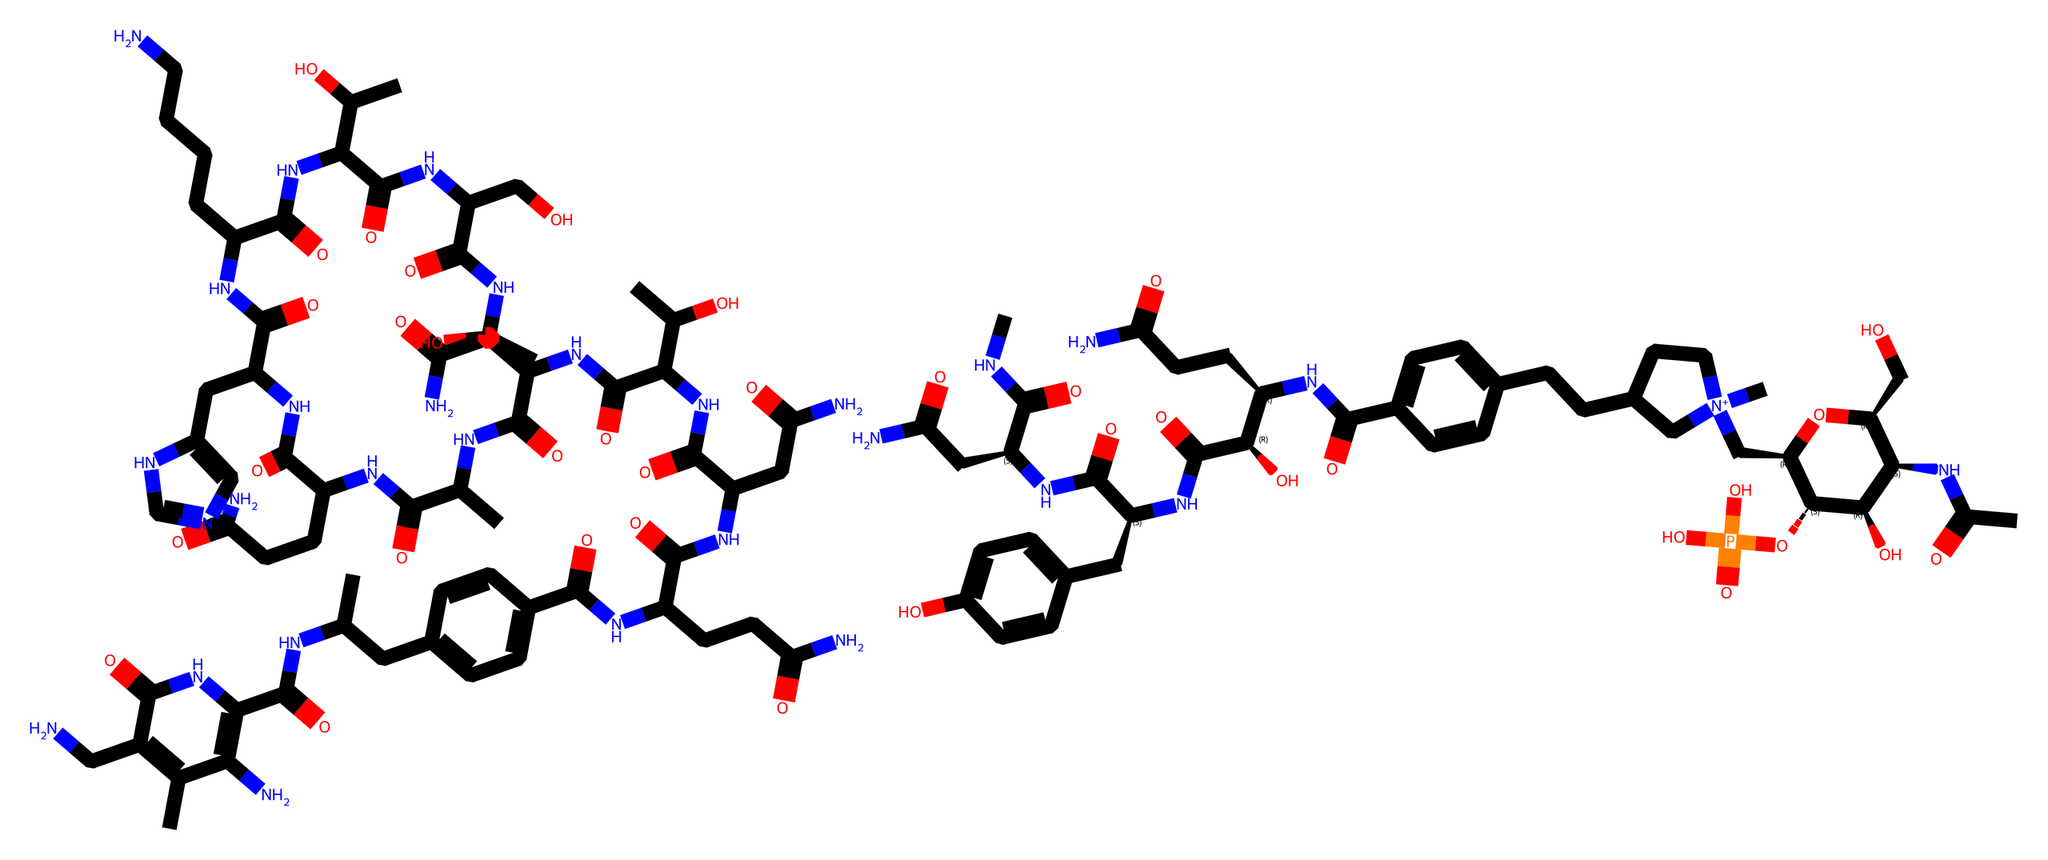What is the molecular formula of vitamin B12? The molecular formula can be derived from the counts of each type of atom present in the SMILES representation. By identifying and summing the occurrences of carbon (C), hydrogen (H), nitrogen (N), and oxygen (O), the molecular formula is calculated to be C63H88CoN14O14P.
Answer: C63H88CoN14O14P How many nitrogen atoms are in the structure? By inspecting the SMILES representation closely, the count of nitrogen (N) atoms can be done by identifying each occurrence within the string. There are 14 nitrogen atoms visible in the structure.
Answer: 14 What is the role of vitamin B12 in neural function? Vitamin B12 plays a crucial role in myelination and synthesis of neurotransmitters, which aids in the proper functioning of the nervous system. Its involvement is essential for preventing neurological disorders.
Answer: myelination Is there a phosphorous atom in this structure? A careful examination of the SMILES string reveals the presence of a phosphate group indicated by OP(=O)(O)O, thus confirming the existence of a phosphorus atom.
Answer: yes What functional groups are present in vitamin B12? By analyzing the structure, it is evident that there are multiple functional groups including amides (due to -C(=O)NH), hydroxyls (-OH), and phosphates (-PO4). The presence of these groups contributes to its biological activity.
Answer: amides, hydroxyls, phosphates How does the structure of vitamin B12 relate to its solubility? The various polar groups, such as hydroxyl and amide functionalities, increase the overall polarity of vitamin B12's structure, which typically enhances its solubility in water and biological fluids.
Answer: polar groups Can you identify any structural components indicating it might be a vitamin? The complexity of the organic structure along with the incorporation of cobalt at the center suggests that this compound is a vitamin. Vitamins typically possess unique arrangements and often contain metal ions like cobalt in the case of vitamin B12.
Answer: cobalt 